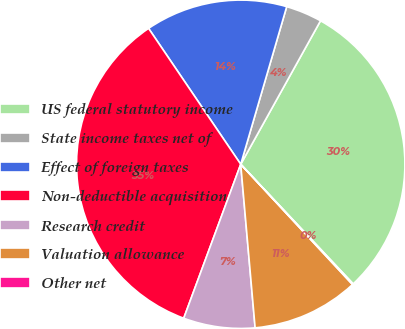Convert chart. <chart><loc_0><loc_0><loc_500><loc_500><pie_chart><fcel>US federal statutory income<fcel>State income taxes net of<fcel>Effect of foreign taxes<fcel>Non-deductible acquisition<fcel>Research credit<fcel>Valuation allowance<fcel>Other net<nl><fcel>29.91%<fcel>3.56%<fcel>14.0%<fcel>34.87%<fcel>7.04%<fcel>10.52%<fcel>0.09%<nl></chart> 